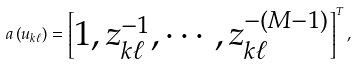<formula> <loc_0><loc_0><loc_500><loc_500>a \left ( u _ { k \ell } \right ) = \begin{bmatrix} 1 , z _ { k \ell } ^ { - 1 } , \cdots , z _ { k \ell } ^ { - ( M - 1 ) } \end{bmatrix} ^ { T } ,</formula> 